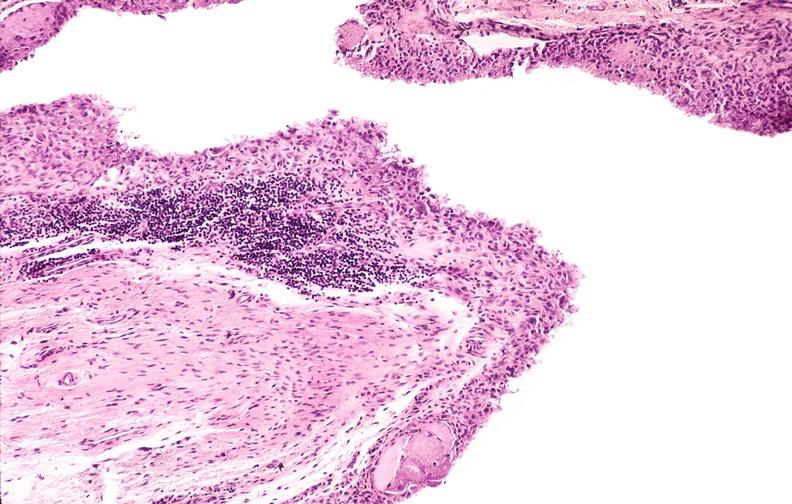does close-up tumor show rheumatoid arthritis, synovial hypertrophy with formation of villi pannus?
Answer the question using a single word or phrase. No 